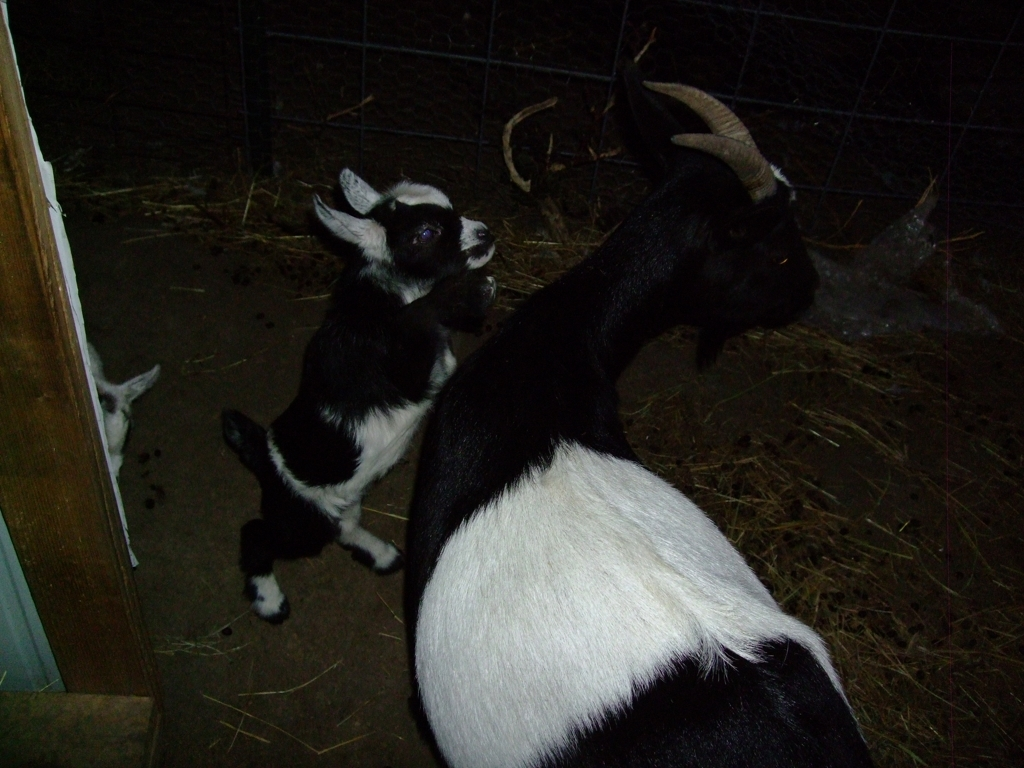Are there any quality issues with this image? The image does exhibit some quality issues such as low lighting which leads to underexposure, making details hard to discern, especially in the shadowed areas. There's also visible digital noise, possibly due to high ISO settings used in a low-light environment, and the image is not sharply focused, which causes a slight blur. 